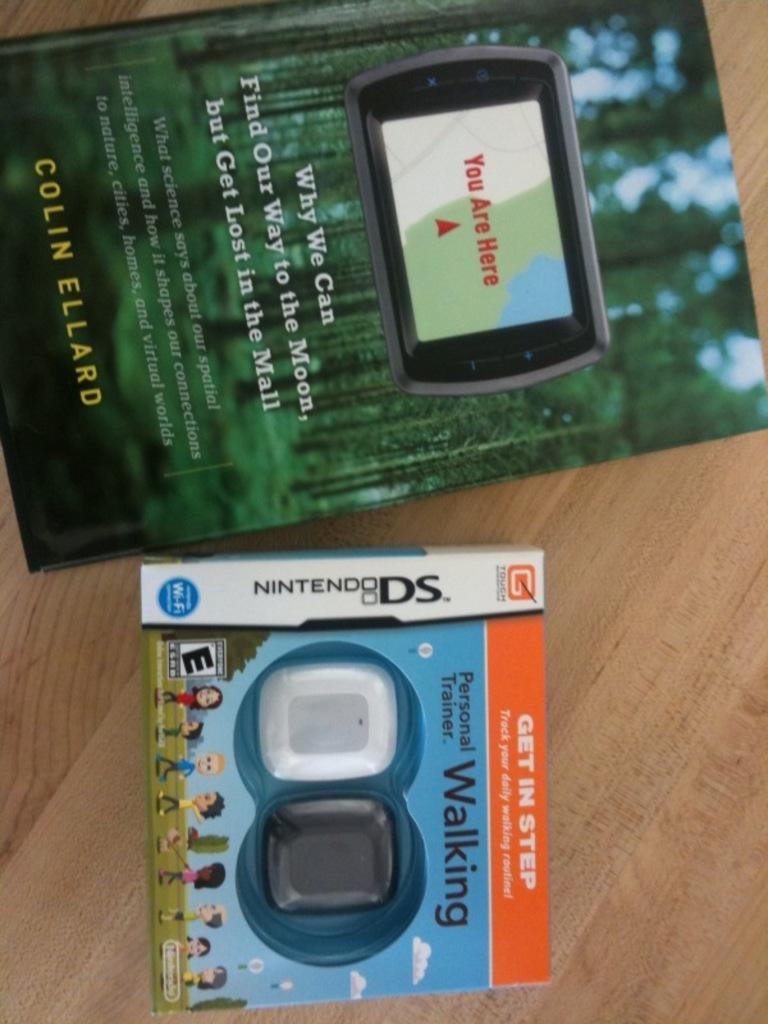<image>
Provide a brief description of the given image. A book titled Why We Can Find Our Way to the Moon but Get Lost in the Mall laying next to a Nintendo DS, 